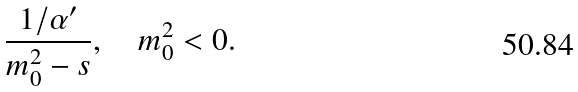Convert formula to latex. <formula><loc_0><loc_0><loc_500><loc_500>\frac { 1 / \alpha ^ { \prime } } { m _ { 0 } ^ { 2 } - s } , \quad m _ { 0 } ^ { 2 } < 0 .</formula> 